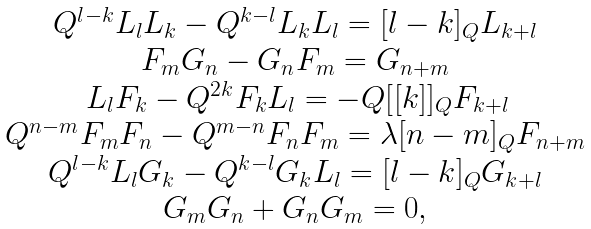Convert formula to latex. <formula><loc_0><loc_0><loc_500><loc_500>\begin{array} { c } Q ^ { l - k } L _ { l } L _ { k } - Q ^ { k - l } L _ { k } L _ { l } = [ l - k ] _ { Q } L _ { k + l } \\ F _ { m } G _ { n } - G _ { n } F _ { m } = G _ { n + m } \\ \, L _ { l } F _ { k } - Q ^ { 2 k } F _ { k } L _ { l } = - Q [ [ k ] ] _ { Q } F _ { k + l } \\ Q ^ { n - m } F _ { m } F _ { n } - Q ^ { m - n } F _ { n } F _ { m } = \lambda [ n - m ] _ { Q } F _ { n + m } \\ Q ^ { l - k } L _ { l } G _ { k } - Q ^ { k - l } G _ { k } L _ { l } = [ l - k ] _ { Q } G _ { k + l } \\ G _ { m } G _ { n } + G _ { n } G _ { m } = 0 , \\ \end{array}</formula> 